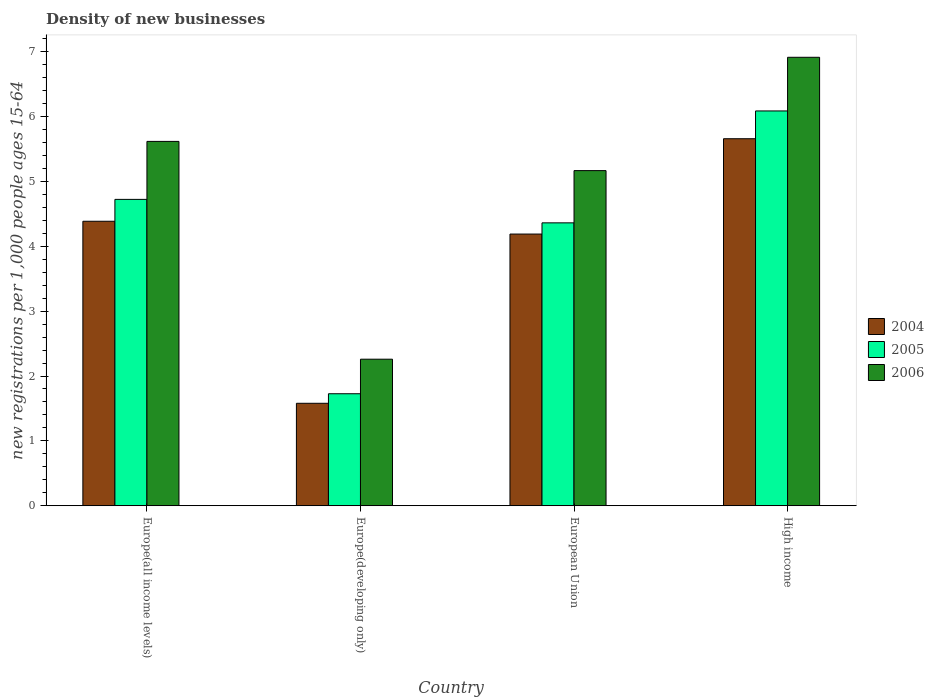How many groups of bars are there?
Your answer should be very brief. 4. Are the number of bars per tick equal to the number of legend labels?
Keep it short and to the point. Yes. Are the number of bars on each tick of the X-axis equal?
Your response must be concise. Yes. How many bars are there on the 4th tick from the left?
Ensure brevity in your answer.  3. What is the number of new registrations in 2004 in European Union?
Keep it short and to the point. 4.19. Across all countries, what is the maximum number of new registrations in 2004?
Keep it short and to the point. 5.66. Across all countries, what is the minimum number of new registrations in 2006?
Ensure brevity in your answer.  2.26. In which country was the number of new registrations in 2004 maximum?
Your answer should be compact. High income. In which country was the number of new registrations in 2005 minimum?
Your response must be concise. Europe(developing only). What is the total number of new registrations in 2004 in the graph?
Your answer should be very brief. 15.81. What is the difference between the number of new registrations in 2006 in Europe(all income levels) and that in European Union?
Make the answer very short. 0.45. What is the difference between the number of new registrations in 2005 in European Union and the number of new registrations in 2006 in Europe(all income levels)?
Provide a succinct answer. -1.26. What is the average number of new registrations in 2004 per country?
Make the answer very short. 3.95. What is the difference between the number of new registrations of/in 2005 and number of new registrations of/in 2004 in Europe(all income levels)?
Your answer should be very brief. 0.34. In how many countries, is the number of new registrations in 2004 greater than 0.2?
Ensure brevity in your answer.  4. What is the ratio of the number of new registrations in 2004 in Europe(developing only) to that in European Union?
Make the answer very short. 0.38. Is the number of new registrations in 2006 in European Union less than that in High income?
Offer a very short reply. Yes. What is the difference between the highest and the second highest number of new registrations in 2004?
Ensure brevity in your answer.  -0.2. What is the difference between the highest and the lowest number of new registrations in 2004?
Offer a very short reply. 4.08. In how many countries, is the number of new registrations in 2005 greater than the average number of new registrations in 2005 taken over all countries?
Offer a very short reply. 3. How many bars are there?
Your answer should be compact. 12. Are all the bars in the graph horizontal?
Give a very brief answer. No. Does the graph contain any zero values?
Keep it short and to the point. No. How many legend labels are there?
Offer a very short reply. 3. What is the title of the graph?
Your answer should be very brief. Density of new businesses. Does "2005" appear as one of the legend labels in the graph?
Your response must be concise. Yes. What is the label or title of the Y-axis?
Ensure brevity in your answer.  New registrations per 1,0 people ages 15-64. What is the new registrations per 1,000 people ages 15-64 in 2004 in Europe(all income levels)?
Your answer should be very brief. 4.39. What is the new registrations per 1,000 people ages 15-64 in 2005 in Europe(all income levels)?
Offer a terse response. 4.72. What is the new registrations per 1,000 people ages 15-64 in 2006 in Europe(all income levels)?
Provide a succinct answer. 5.62. What is the new registrations per 1,000 people ages 15-64 in 2004 in Europe(developing only)?
Make the answer very short. 1.58. What is the new registrations per 1,000 people ages 15-64 of 2005 in Europe(developing only)?
Offer a terse response. 1.73. What is the new registrations per 1,000 people ages 15-64 in 2006 in Europe(developing only)?
Offer a very short reply. 2.26. What is the new registrations per 1,000 people ages 15-64 of 2004 in European Union?
Your answer should be compact. 4.19. What is the new registrations per 1,000 people ages 15-64 in 2005 in European Union?
Make the answer very short. 4.36. What is the new registrations per 1,000 people ages 15-64 in 2006 in European Union?
Your answer should be compact. 5.17. What is the new registrations per 1,000 people ages 15-64 in 2004 in High income?
Offer a very short reply. 5.66. What is the new registrations per 1,000 people ages 15-64 in 2005 in High income?
Provide a short and direct response. 6.09. What is the new registrations per 1,000 people ages 15-64 of 2006 in High income?
Ensure brevity in your answer.  6.91. Across all countries, what is the maximum new registrations per 1,000 people ages 15-64 in 2004?
Offer a very short reply. 5.66. Across all countries, what is the maximum new registrations per 1,000 people ages 15-64 of 2005?
Offer a very short reply. 6.09. Across all countries, what is the maximum new registrations per 1,000 people ages 15-64 of 2006?
Offer a terse response. 6.91. Across all countries, what is the minimum new registrations per 1,000 people ages 15-64 of 2004?
Provide a short and direct response. 1.58. Across all countries, what is the minimum new registrations per 1,000 people ages 15-64 in 2005?
Provide a short and direct response. 1.73. Across all countries, what is the minimum new registrations per 1,000 people ages 15-64 of 2006?
Provide a succinct answer. 2.26. What is the total new registrations per 1,000 people ages 15-64 of 2004 in the graph?
Provide a succinct answer. 15.81. What is the total new registrations per 1,000 people ages 15-64 in 2005 in the graph?
Provide a short and direct response. 16.9. What is the total new registrations per 1,000 people ages 15-64 in 2006 in the graph?
Provide a short and direct response. 19.96. What is the difference between the new registrations per 1,000 people ages 15-64 in 2004 in Europe(all income levels) and that in Europe(developing only)?
Offer a very short reply. 2.81. What is the difference between the new registrations per 1,000 people ages 15-64 of 2005 in Europe(all income levels) and that in Europe(developing only)?
Your answer should be very brief. 3. What is the difference between the new registrations per 1,000 people ages 15-64 of 2006 in Europe(all income levels) and that in Europe(developing only)?
Ensure brevity in your answer.  3.36. What is the difference between the new registrations per 1,000 people ages 15-64 in 2004 in Europe(all income levels) and that in European Union?
Ensure brevity in your answer.  0.2. What is the difference between the new registrations per 1,000 people ages 15-64 of 2005 in Europe(all income levels) and that in European Union?
Your response must be concise. 0.36. What is the difference between the new registrations per 1,000 people ages 15-64 of 2006 in Europe(all income levels) and that in European Union?
Offer a very short reply. 0.45. What is the difference between the new registrations per 1,000 people ages 15-64 in 2004 in Europe(all income levels) and that in High income?
Your answer should be very brief. -1.27. What is the difference between the new registrations per 1,000 people ages 15-64 of 2005 in Europe(all income levels) and that in High income?
Make the answer very short. -1.36. What is the difference between the new registrations per 1,000 people ages 15-64 of 2006 in Europe(all income levels) and that in High income?
Make the answer very short. -1.3. What is the difference between the new registrations per 1,000 people ages 15-64 of 2004 in Europe(developing only) and that in European Union?
Offer a very short reply. -2.61. What is the difference between the new registrations per 1,000 people ages 15-64 in 2005 in Europe(developing only) and that in European Union?
Make the answer very short. -2.64. What is the difference between the new registrations per 1,000 people ages 15-64 in 2006 in Europe(developing only) and that in European Union?
Provide a succinct answer. -2.91. What is the difference between the new registrations per 1,000 people ages 15-64 in 2004 in Europe(developing only) and that in High income?
Give a very brief answer. -4.08. What is the difference between the new registrations per 1,000 people ages 15-64 of 2005 in Europe(developing only) and that in High income?
Offer a very short reply. -4.36. What is the difference between the new registrations per 1,000 people ages 15-64 in 2006 in Europe(developing only) and that in High income?
Ensure brevity in your answer.  -4.66. What is the difference between the new registrations per 1,000 people ages 15-64 in 2004 in European Union and that in High income?
Keep it short and to the point. -1.47. What is the difference between the new registrations per 1,000 people ages 15-64 of 2005 in European Union and that in High income?
Offer a terse response. -1.73. What is the difference between the new registrations per 1,000 people ages 15-64 of 2006 in European Union and that in High income?
Provide a short and direct response. -1.75. What is the difference between the new registrations per 1,000 people ages 15-64 in 2004 in Europe(all income levels) and the new registrations per 1,000 people ages 15-64 in 2005 in Europe(developing only)?
Your answer should be compact. 2.66. What is the difference between the new registrations per 1,000 people ages 15-64 in 2004 in Europe(all income levels) and the new registrations per 1,000 people ages 15-64 in 2006 in Europe(developing only)?
Provide a succinct answer. 2.13. What is the difference between the new registrations per 1,000 people ages 15-64 of 2005 in Europe(all income levels) and the new registrations per 1,000 people ages 15-64 of 2006 in Europe(developing only)?
Your answer should be compact. 2.46. What is the difference between the new registrations per 1,000 people ages 15-64 in 2004 in Europe(all income levels) and the new registrations per 1,000 people ages 15-64 in 2005 in European Union?
Make the answer very short. 0.02. What is the difference between the new registrations per 1,000 people ages 15-64 of 2004 in Europe(all income levels) and the new registrations per 1,000 people ages 15-64 of 2006 in European Union?
Offer a terse response. -0.78. What is the difference between the new registrations per 1,000 people ages 15-64 of 2005 in Europe(all income levels) and the new registrations per 1,000 people ages 15-64 of 2006 in European Union?
Provide a succinct answer. -0.44. What is the difference between the new registrations per 1,000 people ages 15-64 of 2004 in Europe(all income levels) and the new registrations per 1,000 people ages 15-64 of 2005 in High income?
Your response must be concise. -1.7. What is the difference between the new registrations per 1,000 people ages 15-64 of 2004 in Europe(all income levels) and the new registrations per 1,000 people ages 15-64 of 2006 in High income?
Your answer should be compact. -2.53. What is the difference between the new registrations per 1,000 people ages 15-64 in 2005 in Europe(all income levels) and the new registrations per 1,000 people ages 15-64 in 2006 in High income?
Provide a short and direct response. -2.19. What is the difference between the new registrations per 1,000 people ages 15-64 of 2004 in Europe(developing only) and the new registrations per 1,000 people ages 15-64 of 2005 in European Union?
Offer a terse response. -2.78. What is the difference between the new registrations per 1,000 people ages 15-64 of 2004 in Europe(developing only) and the new registrations per 1,000 people ages 15-64 of 2006 in European Union?
Offer a terse response. -3.59. What is the difference between the new registrations per 1,000 people ages 15-64 in 2005 in Europe(developing only) and the new registrations per 1,000 people ages 15-64 in 2006 in European Union?
Provide a succinct answer. -3.44. What is the difference between the new registrations per 1,000 people ages 15-64 in 2004 in Europe(developing only) and the new registrations per 1,000 people ages 15-64 in 2005 in High income?
Provide a succinct answer. -4.51. What is the difference between the new registrations per 1,000 people ages 15-64 of 2004 in Europe(developing only) and the new registrations per 1,000 people ages 15-64 of 2006 in High income?
Your answer should be very brief. -5.33. What is the difference between the new registrations per 1,000 people ages 15-64 of 2005 in Europe(developing only) and the new registrations per 1,000 people ages 15-64 of 2006 in High income?
Your answer should be compact. -5.19. What is the difference between the new registrations per 1,000 people ages 15-64 in 2004 in European Union and the new registrations per 1,000 people ages 15-64 in 2005 in High income?
Offer a very short reply. -1.9. What is the difference between the new registrations per 1,000 people ages 15-64 of 2004 in European Union and the new registrations per 1,000 people ages 15-64 of 2006 in High income?
Give a very brief answer. -2.73. What is the difference between the new registrations per 1,000 people ages 15-64 of 2005 in European Union and the new registrations per 1,000 people ages 15-64 of 2006 in High income?
Your answer should be compact. -2.55. What is the average new registrations per 1,000 people ages 15-64 in 2004 per country?
Keep it short and to the point. 3.95. What is the average new registrations per 1,000 people ages 15-64 in 2005 per country?
Your answer should be compact. 4.22. What is the average new registrations per 1,000 people ages 15-64 in 2006 per country?
Provide a succinct answer. 4.99. What is the difference between the new registrations per 1,000 people ages 15-64 in 2004 and new registrations per 1,000 people ages 15-64 in 2005 in Europe(all income levels)?
Your answer should be very brief. -0.34. What is the difference between the new registrations per 1,000 people ages 15-64 of 2004 and new registrations per 1,000 people ages 15-64 of 2006 in Europe(all income levels)?
Your answer should be compact. -1.23. What is the difference between the new registrations per 1,000 people ages 15-64 in 2005 and new registrations per 1,000 people ages 15-64 in 2006 in Europe(all income levels)?
Ensure brevity in your answer.  -0.89. What is the difference between the new registrations per 1,000 people ages 15-64 in 2004 and new registrations per 1,000 people ages 15-64 in 2005 in Europe(developing only)?
Your answer should be compact. -0.15. What is the difference between the new registrations per 1,000 people ages 15-64 in 2004 and new registrations per 1,000 people ages 15-64 in 2006 in Europe(developing only)?
Your answer should be very brief. -0.68. What is the difference between the new registrations per 1,000 people ages 15-64 of 2005 and new registrations per 1,000 people ages 15-64 of 2006 in Europe(developing only)?
Ensure brevity in your answer.  -0.53. What is the difference between the new registrations per 1,000 people ages 15-64 in 2004 and new registrations per 1,000 people ages 15-64 in 2005 in European Union?
Provide a succinct answer. -0.17. What is the difference between the new registrations per 1,000 people ages 15-64 in 2004 and new registrations per 1,000 people ages 15-64 in 2006 in European Union?
Provide a succinct answer. -0.98. What is the difference between the new registrations per 1,000 people ages 15-64 in 2005 and new registrations per 1,000 people ages 15-64 in 2006 in European Union?
Offer a terse response. -0.81. What is the difference between the new registrations per 1,000 people ages 15-64 of 2004 and new registrations per 1,000 people ages 15-64 of 2005 in High income?
Your answer should be very brief. -0.43. What is the difference between the new registrations per 1,000 people ages 15-64 of 2004 and new registrations per 1,000 people ages 15-64 of 2006 in High income?
Provide a short and direct response. -1.26. What is the difference between the new registrations per 1,000 people ages 15-64 in 2005 and new registrations per 1,000 people ages 15-64 in 2006 in High income?
Keep it short and to the point. -0.83. What is the ratio of the new registrations per 1,000 people ages 15-64 of 2004 in Europe(all income levels) to that in Europe(developing only)?
Your answer should be very brief. 2.78. What is the ratio of the new registrations per 1,000 people ages 15-64 in 2005 in Europe(all income levels) to that in Europe(developing only)?
Your response must be concise. 2.74. What is the ratio of the new registrations per 1,000 people ages 15-64 in 2006 in Europe(all income levels) to that in Europe(developing only)?
Your answer should be compact. 2.49. What is the ratio of the new registrations per 1,000 people ages 15-64 in 2004 in Europe(all income levels) to that in European Union?
Your response must be concise. 1.05. What is the ratio of the new registrations per 1,000 people ages 15-64 of 2005 in Europe(all income levels) to that in European Union?
Your answer should be very brief. 1.08. What is the ratio of the new registrations per 1,000 people ages 15-64 in 2006 in Europe(all income levels) to that in European Union?
Offer a very short reply. 1.09. What is the ratio of the new registrations per 1,000 people ages 15-64 of 2004 in Europe(all income levels) to that in High income?
Provide a succinct answer. 0.78. What is the ratio of the new registrations per 1,000 people ages 15-64 of 2005 in Europe(all income levels) to that in High income?
Provide a succinct answer. 0.78. What is the ratio of the new registrations per 1,000 people ages 15-64 in 2006 in Europe(all income levels) to that in High income?
Give a very brief answer. 0.81. What is the ratio of the new registrations per 1,000 people ages 15-64 in 2004 in Europe(developing only) to that in European Union?
Give a very brief answer. 0.38. What is the ratio of the new registrations per 1,000 people ages 15-64 in 2005 in Europe(developing only) to that in European Union?
Provide a short and direct response. 0.4. What is the ratio of the new registrations per 1,000 people ages 15-64 in 2006 in Europe(developing only) to that in European Union?
Offer a very short reply. 0.44. What is the ratio of the new registrations per 1,000 people ages 15-64 in 2004 in Europe(developing only) to that in High income?
Ensure brevity in your answer.  0.28. What is the ratio of the new registrations per 1,000 people ages 15-64 of 2005 in Europe(developing only) to that in High income?
Offer a terse response. 0.28. What is the ratio of the new registrations per 1,000 people ages 15-64 of 2006 in Europe(developing only) to that in High income?
Offer a very short reply. 0.33. What is the ratio of the new registrations per 1,000 people ages 15-64 in 2004 in European Union to that in High income?
Keep it short and to the point. 0.74. What is the ratio of the new registrations per 1,000 people ages 15-64 in 2005 in European Union to that in High income?
Ensure brevity in your answer.  0.72. What is the ratio of the new registrations per 1,000 people ages 15-64 in 2006 in European Union to that in High income?
Provide a succinct answer. 0.75. What is the difference between the highest and the second highest new registrations per 1,000 people ages 15-64 in 2004?
Make the answer very short. 1.27. What is the difference between the highest and the second highest new registrations per 1,000 people ages 15-64 in 2005?
Your answer should be very brief. 1.36. What is the difference between the highest and the second highest new registrations per 1,000 people ages 15-64 of 2006?
Offer a very short reply. 1.3. What is the difference between the highest and the lowest new registrations per 1,000 people ages 15-64 of 2004?
Keep it short and to the point. 4.08. What is the difference between the highest and the lowest new registrations per 1,000 people ages 15-64 in 2005?
Ensure brevity in your answer.  4.36. What is the difference between the highest and the lowest new registrations per 1,000 people ages 15-64 in 2006?
Your response must be concise. 4.66. 